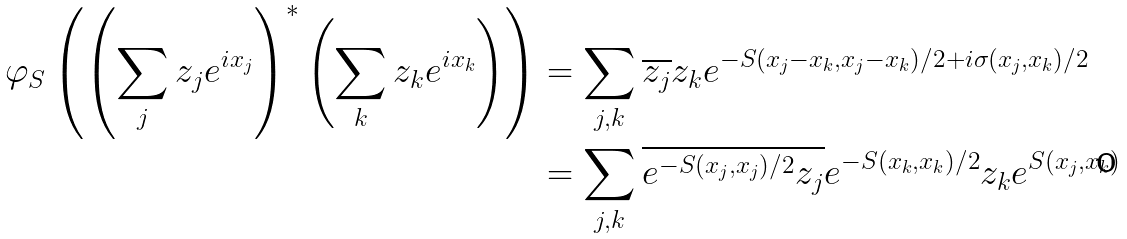Convert formula to latex. <formula><loc_0><loc_0><loc_500><loc_500>\varphi _ { S } \left ( \left ( \sum _ { j } z _ { j } e ^ { i x _ { j } } \right ) ^ { * } \left ( \sum _ { k } z _ { k } e ^ { i x _ { k } } \right ) \right ) & = \sum _ { j , k } \overline { z _ { j } } z _ { k } e ^ { - S ( x _ { j } - x _ { k } , x _ { j } - x _ { k } ) / 2 + i \sigma ( x _ { j } , x _ { k } ) / 2 } \\ & = \sum _ { j , k } \overline { e ^ { - S ( x _ { j } , x _ { j } ) / 2 } z _ { j } } e ^ { - S ( x _ { k } , x _ { k } ) / 2 } z _ { k } e ^ { S ( x _ { j } , x _ { k } ) }</formula> 